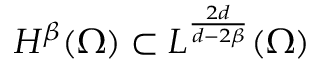<formula> <loc_0><loc_0><loc_500><loc_500>H ^ { \beta } ( \Omega ) \subset L ^ { \frac { 2 d } { d - 2 \beta } } ( \Omega )</formula> 